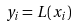<formula> <loc_0><loc_0><loc_500><loc_500>y _ { i } = L ( x _ { i } )</formula> 